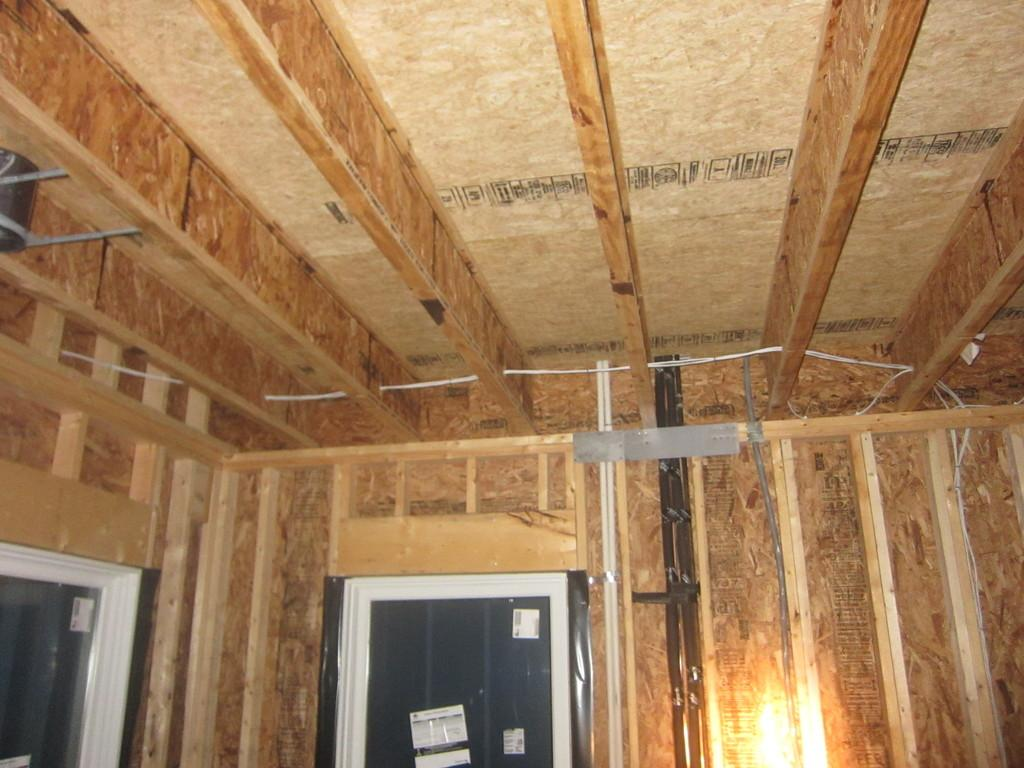What type of location is depicted in the image? The image is an inside view of a house. What architectural features can be seen in the image? There are doors visible in the image. What source of illumination is present in the image? There is a light in the image. What type of meat is being cooked on the train in the image? There are no trains or meat present in the image; it is an inside view of a house with doors and a light. 